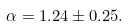Convert formula to latex. <formula><loc_0><loc_0><loc_500><loc_500>\alpha = 1 . 2 4 \pm 0 . 2 5 .</formula> 